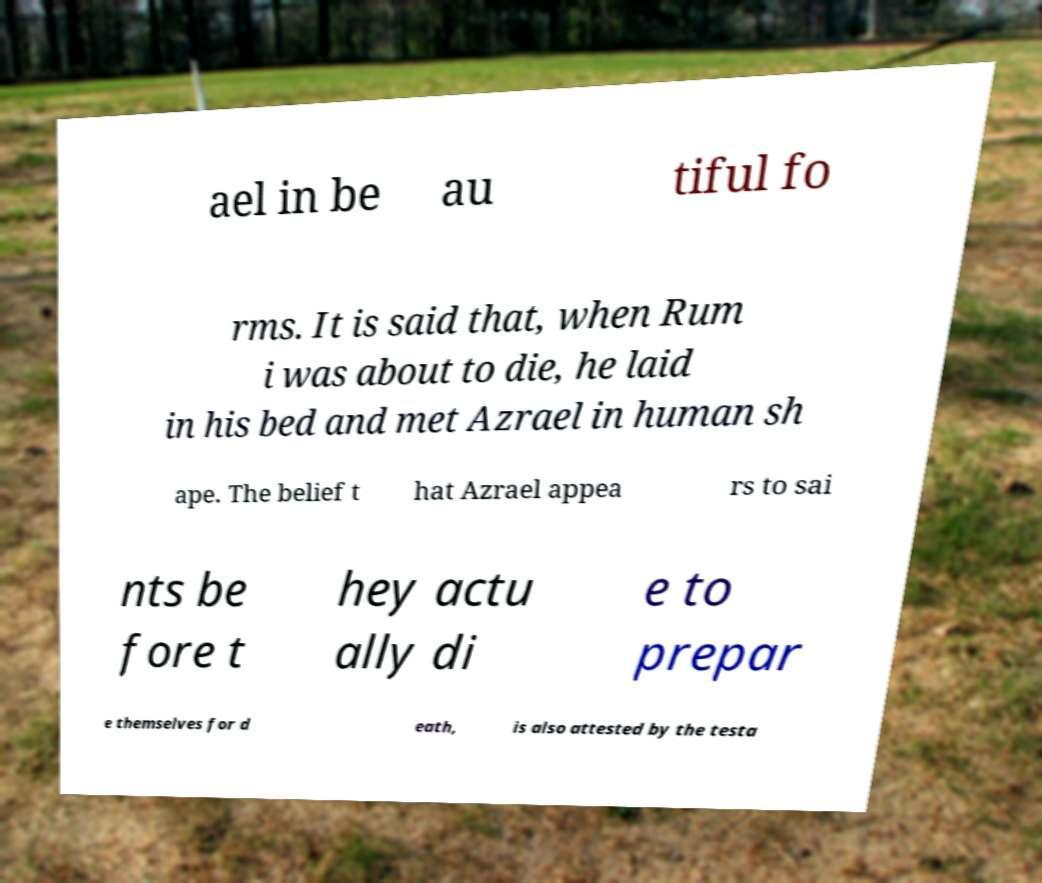Please read and relay the text visible in this image. What does it say? ael in be au tiful fo rms. It is said that, when Rum i was about to die, he laid in his bed and met Azrael in human sh ape. The belief t hat Azrael appea rs to sai nts be fore t hey actu ally di e to prepar e themselves for d eath, is also attested by the testa 